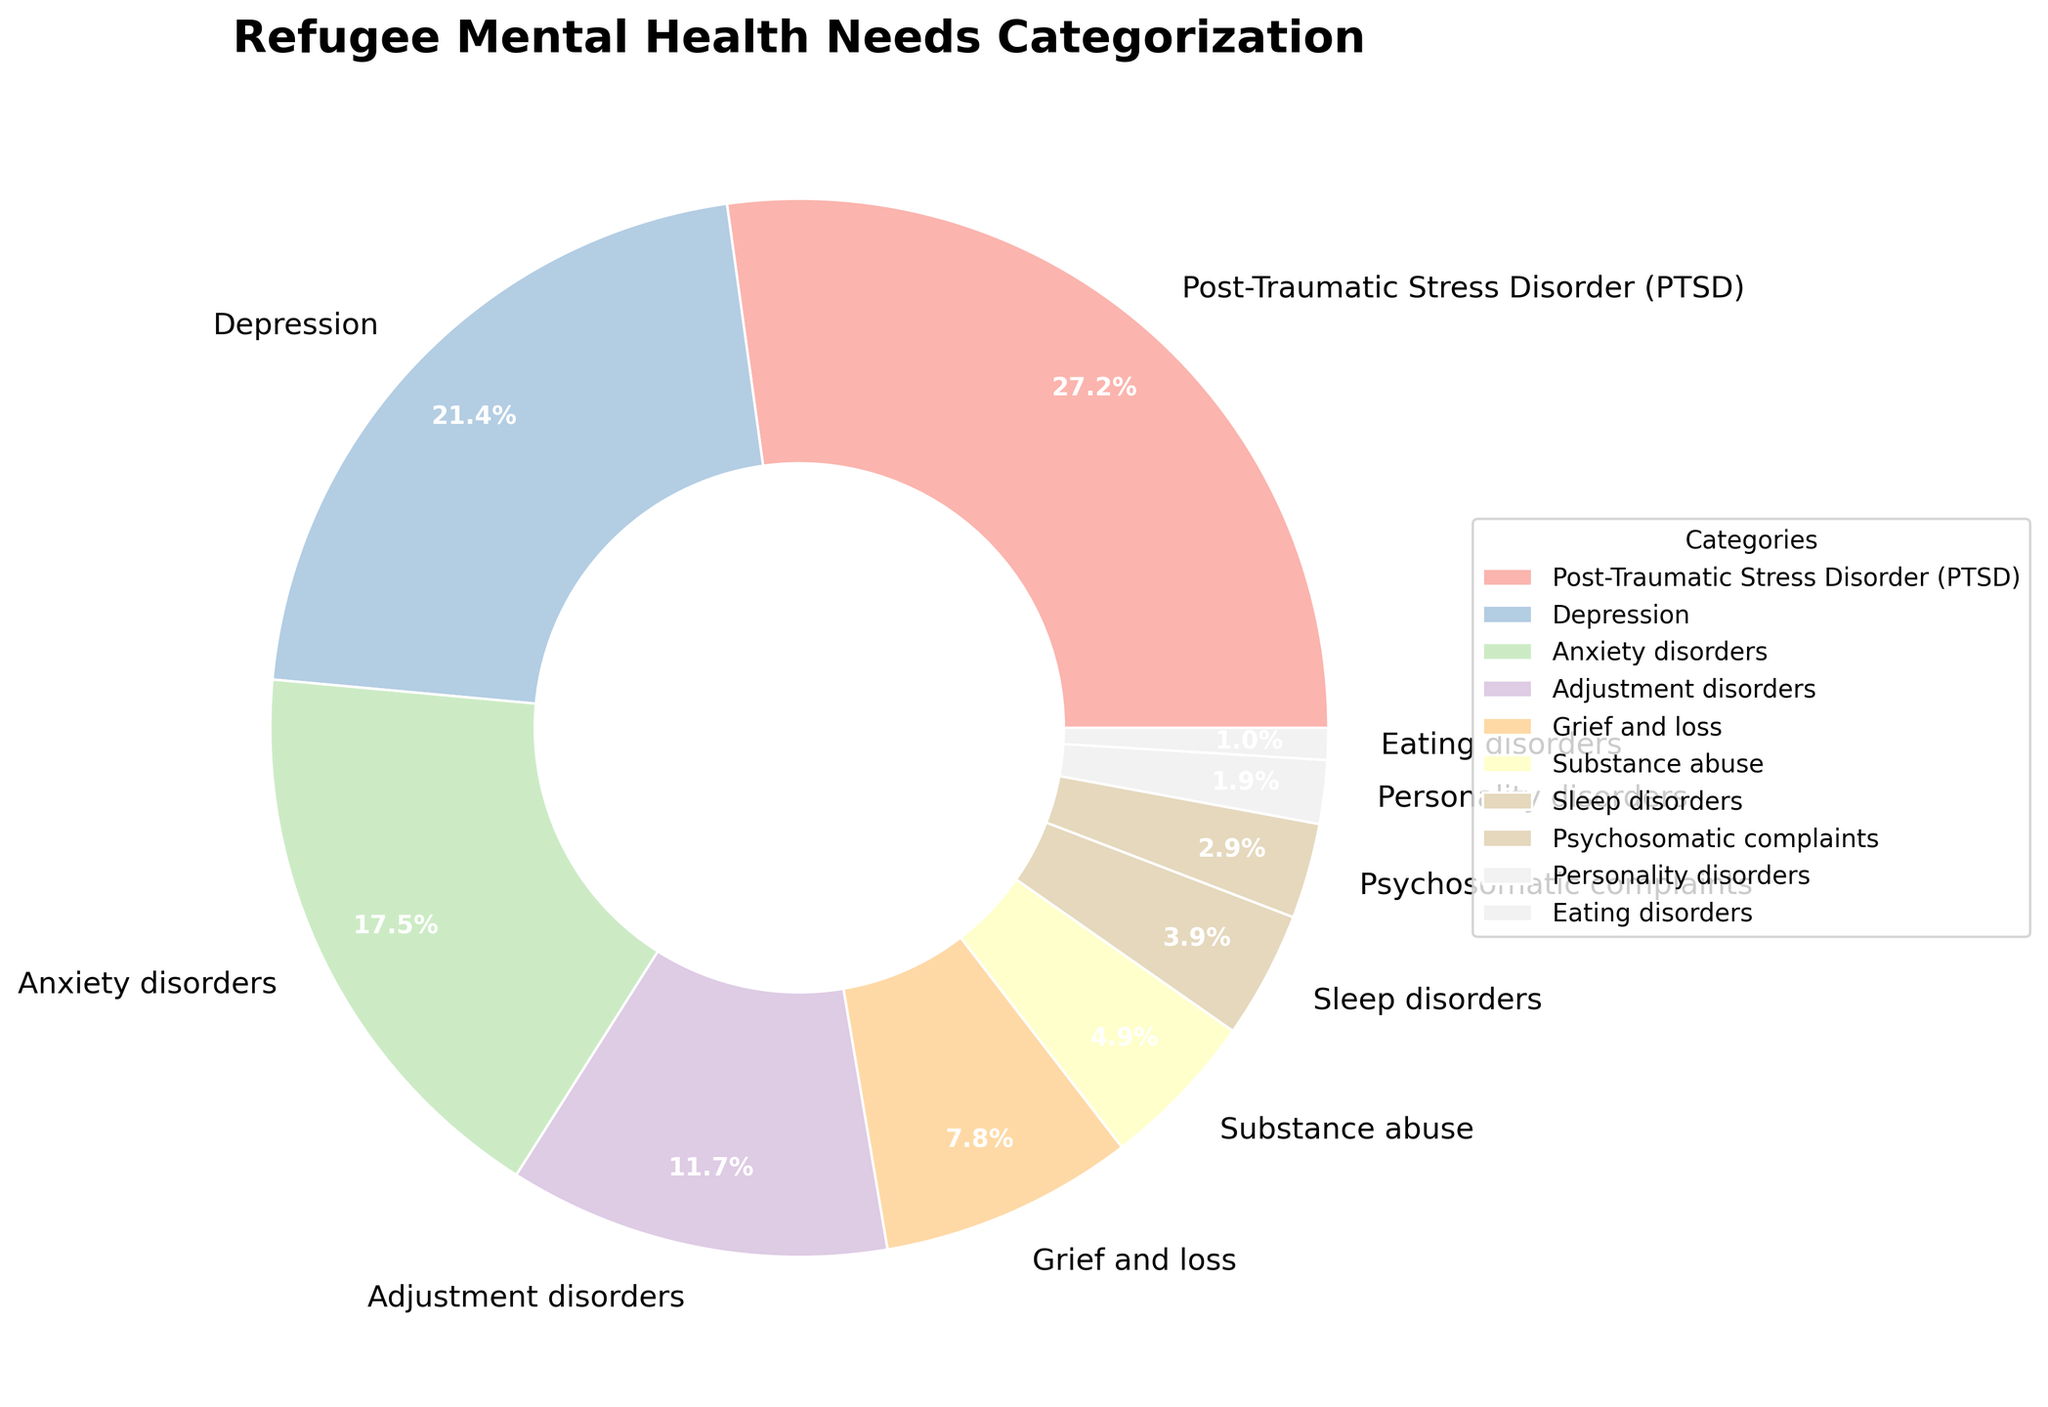What's the most common mental health need among refugees according to the pie chart? The largest section of the pie chart is labeled "Post-Traumatic Stress Disorder (PTSD)" and it occupies 28% of the chart, indicating that PTSD is the most common mental health need.
Answer: Post-Traumatic Stress Disorder (PTSD) Compare the percentages of refugees experiencing Depression and Anxiety disorders. Which is higher? Depression has a percentage of 22%, while Anxiety disorders have a percentage of 18%, which means Depression is higher.
Answer: Depression What is the combined percentage of refugees experiencing Adjustment disorders and Grief and loss? Adjustment disorders account for 12% and Grief and loss accounts for 8%. Adding these together gives 12% + 8% = 20%.
Answer: 20% Which mental health need category occupies the smallest portion of the pie chart? The smallest section of the pie chart is labeled "Eating disorders" and it occupies 1% of the chart.
Answer: Eating disorders What fraction of the pie chart is made up by Substance abuse and Sleep disorders combined? Substance abuse occupies 5% and Sleep disorders occupy 4%. Adding these together gives 5% + 4% = 9%. To convert this into a fraction of the pie chart, it's 9/100 or approximately 9%.
Answer: 9% Which category has a larger percentage: Psychosomatic complaints or Personality disorders? Psychosomatic complaints have a percentage of 3%, while Personality disorders have a percentage of 2%, which means Psychosomatic complaints is larger.
Answer: Psychosomatic complaints How many categories have a percentage greater than 10%? The categories with percentages greater than 10% are Post-Traumatic Stress Disorder (28%), Depression (22%), Anxiety disorders (18%), and Adjustment disorders (12%). This totals to four categories.
Answer: 4 What is the combined percentage of all categories listed other than Post-Traumatic Stress Disorder? The percentages for all other categories are: Depression (22%), Anxiety disorders (18%), Adjustment disorders (12%), Grief and loss (8%), Substance abuse (5%), Sleep disorders (4%), Psychosomatic complaints (3%), Personality disorders (2%), and Eating disorders (1%). Adding these gives 22% + 18% + 12% + 8% + 5% + 4% + 3% + 2% + 1% = 75%.
Answer: 75% Compare the size of the wedge representing Adjustment disorders to the wedge representing Grief and loss. How many times larger is it? Adjustment disorders account for 12%, while Grief and loss accounts for 8%. To find how many times larger Adjustment disorders is, divide 12% by 8%: 12 / 8 = 1.5 times larger.
Answer: 1.5 times What portion of the pie chart is taken up by categories related to specific disorders (PTSD, Anxiety, and Adjustment disorders)? The percentages are: PTSD (28%), Anxiety disorders (18%), and Adjustment disorders (12%). Adding these gives 28% + 18% + 12% = 58%.
Answer: 58% 